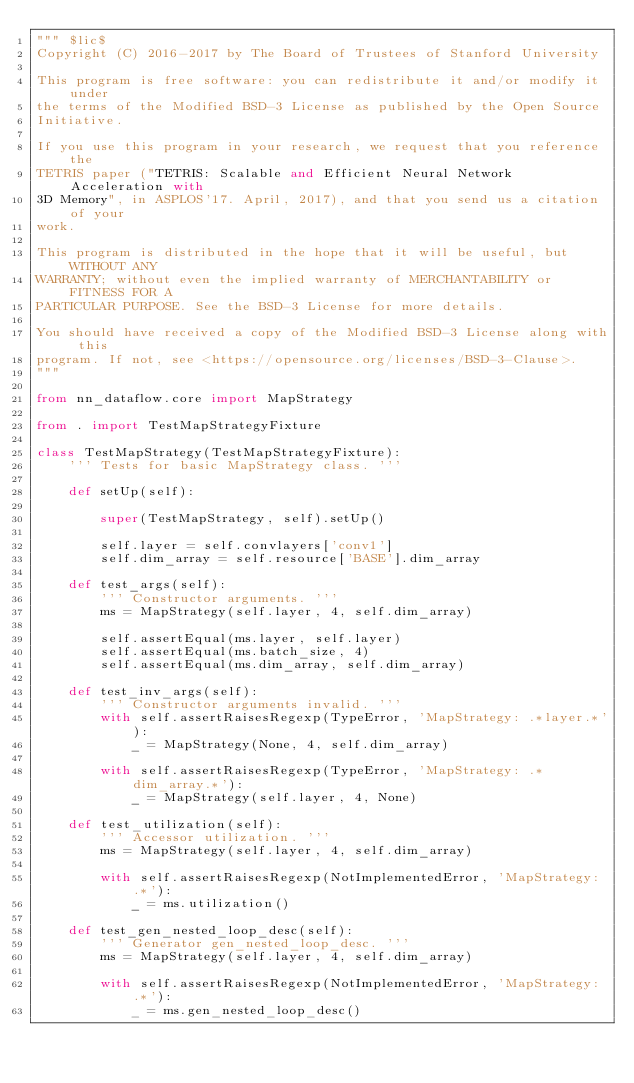Convert code to text. <code><loc_0><loc_0><loc_500><loc_500><_Python_>""" $lic$
Copyright (C) 2016-2017 by The Board of Trustees of Stanford University

This program is free software: you can redistribute it and/or modify it under
the terms of the Modified BSD-3 License as published by the Open Source
Initiative.

If you use this program in your research, we request that you reference the
TETRIS paper ("TETRIS: Scalable and Efficient Neural Network Acceleration with
3D Memory", in ASPLOS'17. April, 2017), and that you send us a citation of your
work.

This program is distributed in the hope that it will be useful, but WITHOUT ANY
WARRANTY; without even the implied warranty of MERCHANTABILITY or FITNESS FOR A
PARTICULAR PURPOSE. See the BSD-3 License for more details.

You should have received a copy of the Modified BSD-3 License along with this
program. If not, see <https://opensource.org/licenses/BSD-3-Clause>.
"""

from nn_dataflow.core import MapStrategy

from . import TestMapStrategyFixture

class TestMapStrategy(TestMapStrategyFixture):
    ''' Tests for basic MapStrategy class. '''

    def setUp(self):

        super(TestMapStrategy, self).setUp()

        self.layer = self.convlayers['conv1']
        self.dim_array = self.resource['BASE'].dim_array

    def test_args(self):
        ''' Constructor arguments. '''
        ms = MapStrategy(self.layer, 4, self.dim_array)

        self.assertEqual(ms.layer, self.layer)
        self.assertEqual(ms.batch_size, 4)
        self.assertEqual(ms.dim_array, self.dim_array)

    def test_inv_args(self):
        ''' Constructor arguments invalid. '''
        with self.assertRaisesRegexp(TypeError, 'MapStrategy: .*layer.*'):
            _ = MapStrategy(None, 4, self.dim_array)

        with self.assertRaisesRegexp(TypeError, 'MapStrategy: .*dim_array.*'):
            _ = MapStrategy(self.layer, 4, None)

    def test_utilization(self):
        ''' Accessor utilization. '''
        ms = MapStrategy(self.layer, 4, self.dim_array)

        with self.assertRaisesRegexp(NotImplementedError, 'MapStrategy: .*'):
            _ = ms.utilization()

    def test_gen_nested_loop_desc(self):
        ''' Generator gen_nested_loop_desc. '''
        ms = MapStrategy(self.layer, 4, self.dim_array)

        with self.assertRaisesRegexp(NotImplementedError, 'MapStrategy: .*'):
            _ = ms.gen_nested_loop_desc()

</code> 